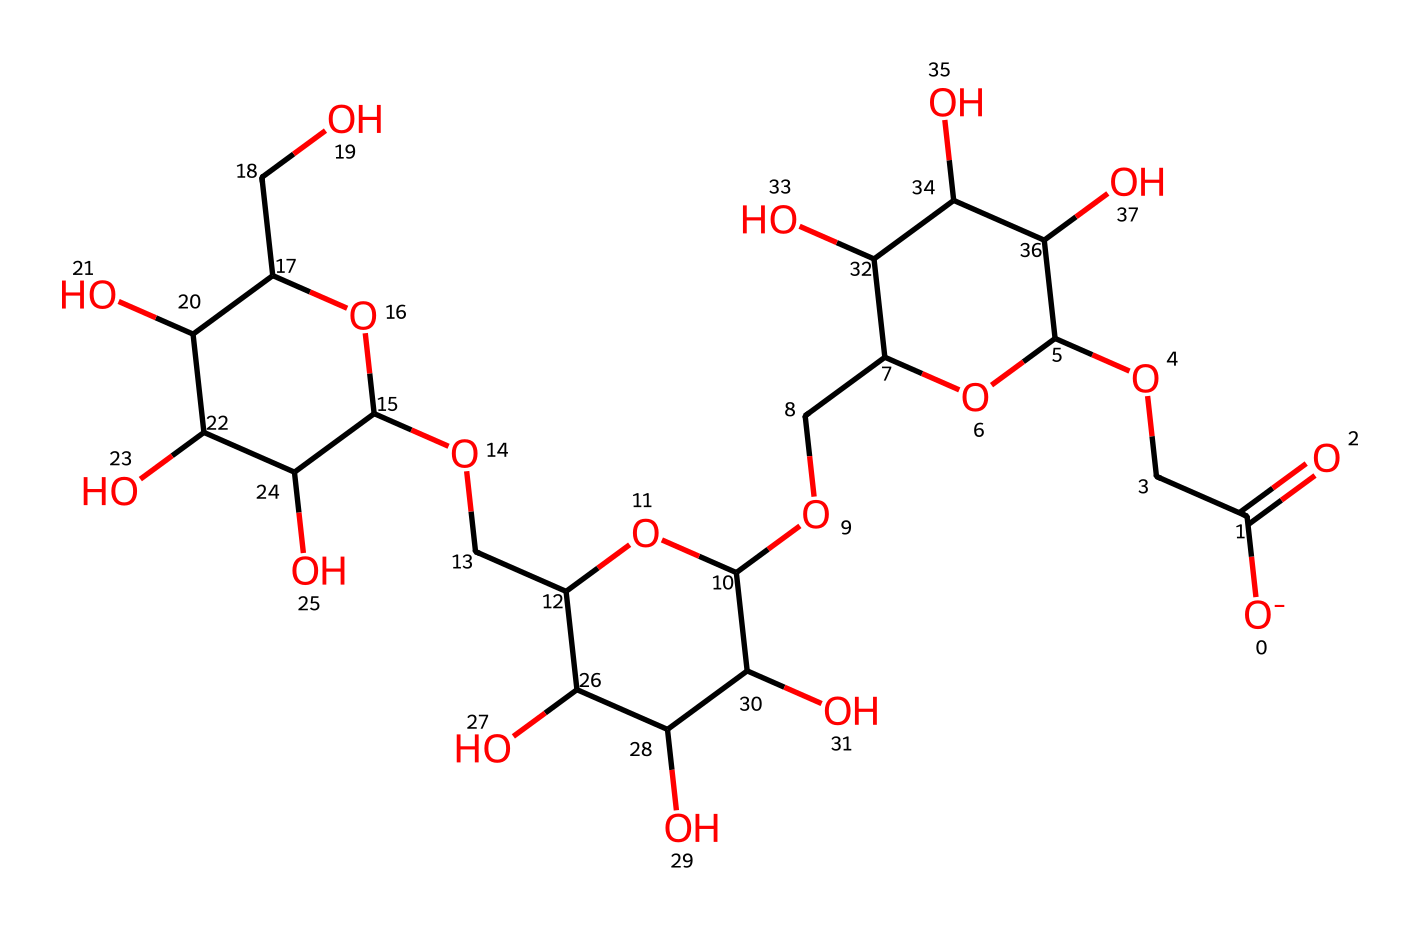What is the molecular formula of carboxymethyl cellulose derived from the SMILES? By interpreting the SMILES string, we can count the number of carbon (C), hydrogen (H), and oxygen (O) atoms present. The total number of each type gives the molecular formula. After counting, we have 76 carbons, 142 hydrogens, and 62 oxygens.
Answer: C76H142O62 How many rings are present in the structure? Analyzing the SMILES string reveals the presence of cyclic structures, specifically observing segments that seem to form rings. Upon careful inspection, we can identify 4 rings within the structure based on the connectivity of the atoms.
Answer: 4 What functional group is present in carboxymethyl cellulose? By examining the structure, we can identify the specific segments that correspond to functional groups. The carboxymethyl group (-COOH) indicates that it contains a carboxyl functional group, confirming its presence in the structure.
Answer: carboxyl group What type of non-Newtonian fluid behavior does carboxymethyl cellulose exhibit? Understanding the properties of carboxymethyl cellulose indicates that it acts as a shear-thinning fluid, which means its viscosity decreases under shear stress. This characteristic behavior is fundamental to its application as a non-Newtonian fluid.
Answer: shear-thinning From the SMILES, how many hydroxyl (-OH) groups can be identified in the structure? The SMILES representation shows multiple connections to oxygen atoms bonded to hydrogen (hydroxyl groups). By examining these connections, we can identify a total of 10 hydroxyl groups present in the molecule based on the number of -OH connections indicated.
Answer: 10 What is the primary industrial application of carboxymethyl cellulose? By considering the properties of carboxymethyl cellulose, it is prominently used in industries for its thickening and emulsifying agents, especially in food products and personal care items. This widespread application speaks to its effectiveness in various formulations.
Answer: thickening agent 